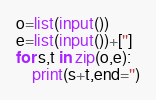<code> <loc_0><loc_0><loc_500><loc_500><_Python_>o=list(input())
e=list(input())+['']
for s,t in zip(o,e):
    print(s+t,end='')
</code> 